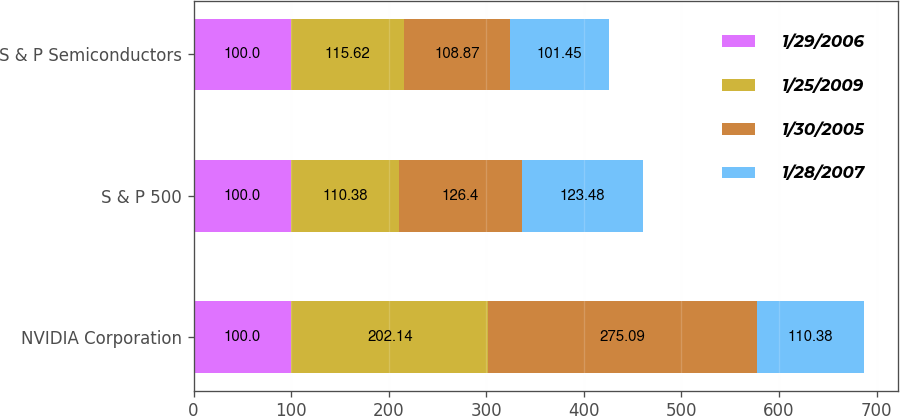Convert chart to OTSL. <chart><loc_0><loc_0><loc_500><loc_500><stacked_bar_chart><ecel><fcel>NVIDIA Corporation<fcel>S & P 500<fcel>S & P Semiconductors<nl><fcel>1/29/2006<fcel>100<fcel>100<fcel>100<nl><fcel>1/25/2009<fcel>202.14<fcel>110.38<fcel>115.62<nl><fcel>1/30/2005<fcel>275.09<fcel>126.4<fcel>108.87<nl><fcel>1/28/2007<fcel>110.38<fcel>123.48<fcel>101.45<nl></chart> 